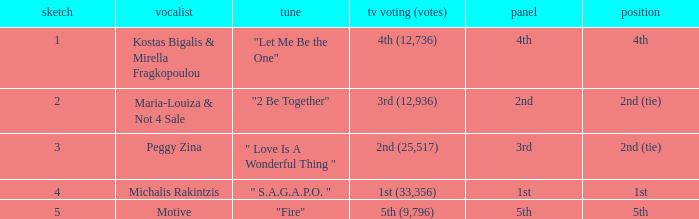Singer Maria-Louiza & Not 4 Sale had what jury? 2nd. 